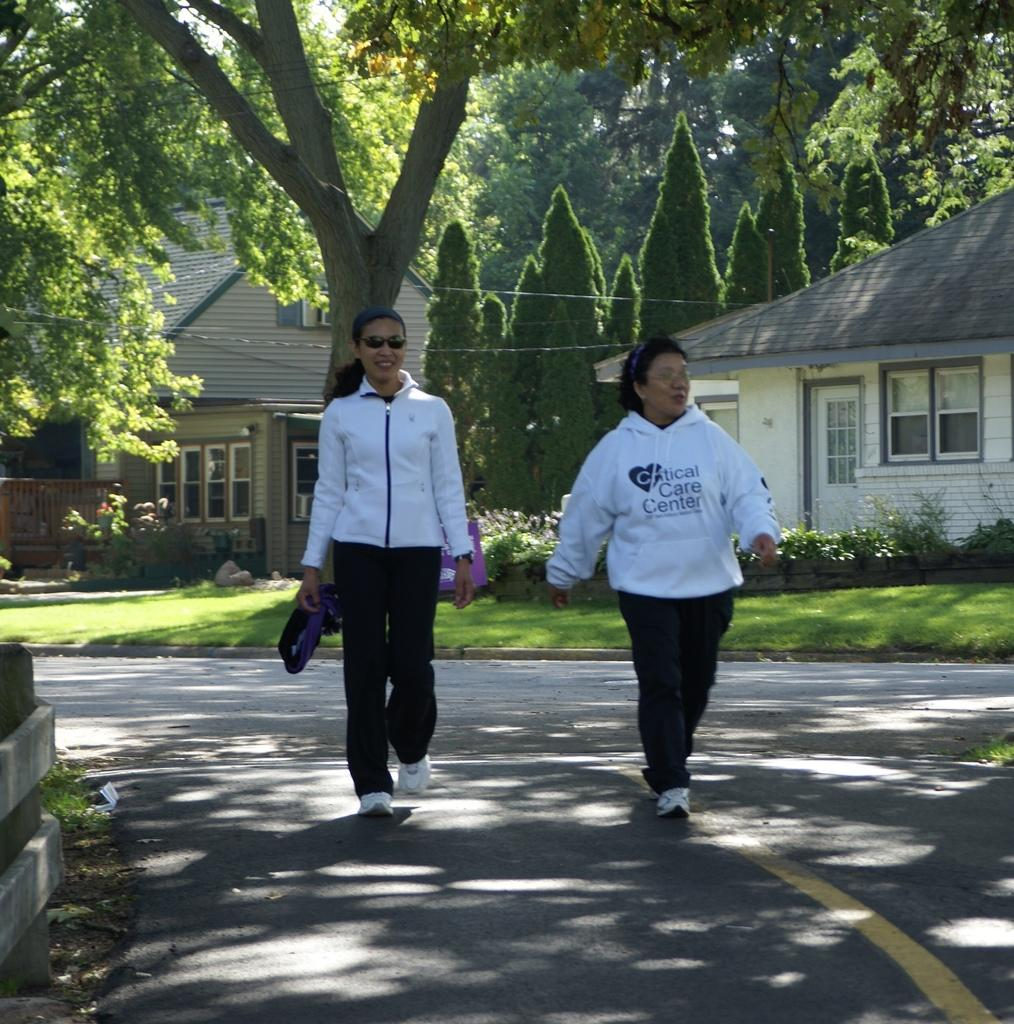How many women are in the image? There are two women in the image. What are the women wearing? The women are wearing white dresses. What are the women doing in the image? The women are walking on a road. What can be seen in the background of the image? There are trees and houses visible in the background of the image. What type of branch is the women using to fly in the image? There is no branch or flying activity present in the image; the women are simply walking on a road. 